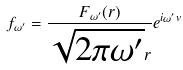<formula> <loc_0><loc_0><loc_500><loc_500>f _ { \omega ^ { \prime } } = \frac { F _ { \omega ^ { \prime } } ( r ) } { \sqrt { 2 \pi \omega ^ { \prime } } r } e ^ { i \omega ^ { \prime } v }</formula> 